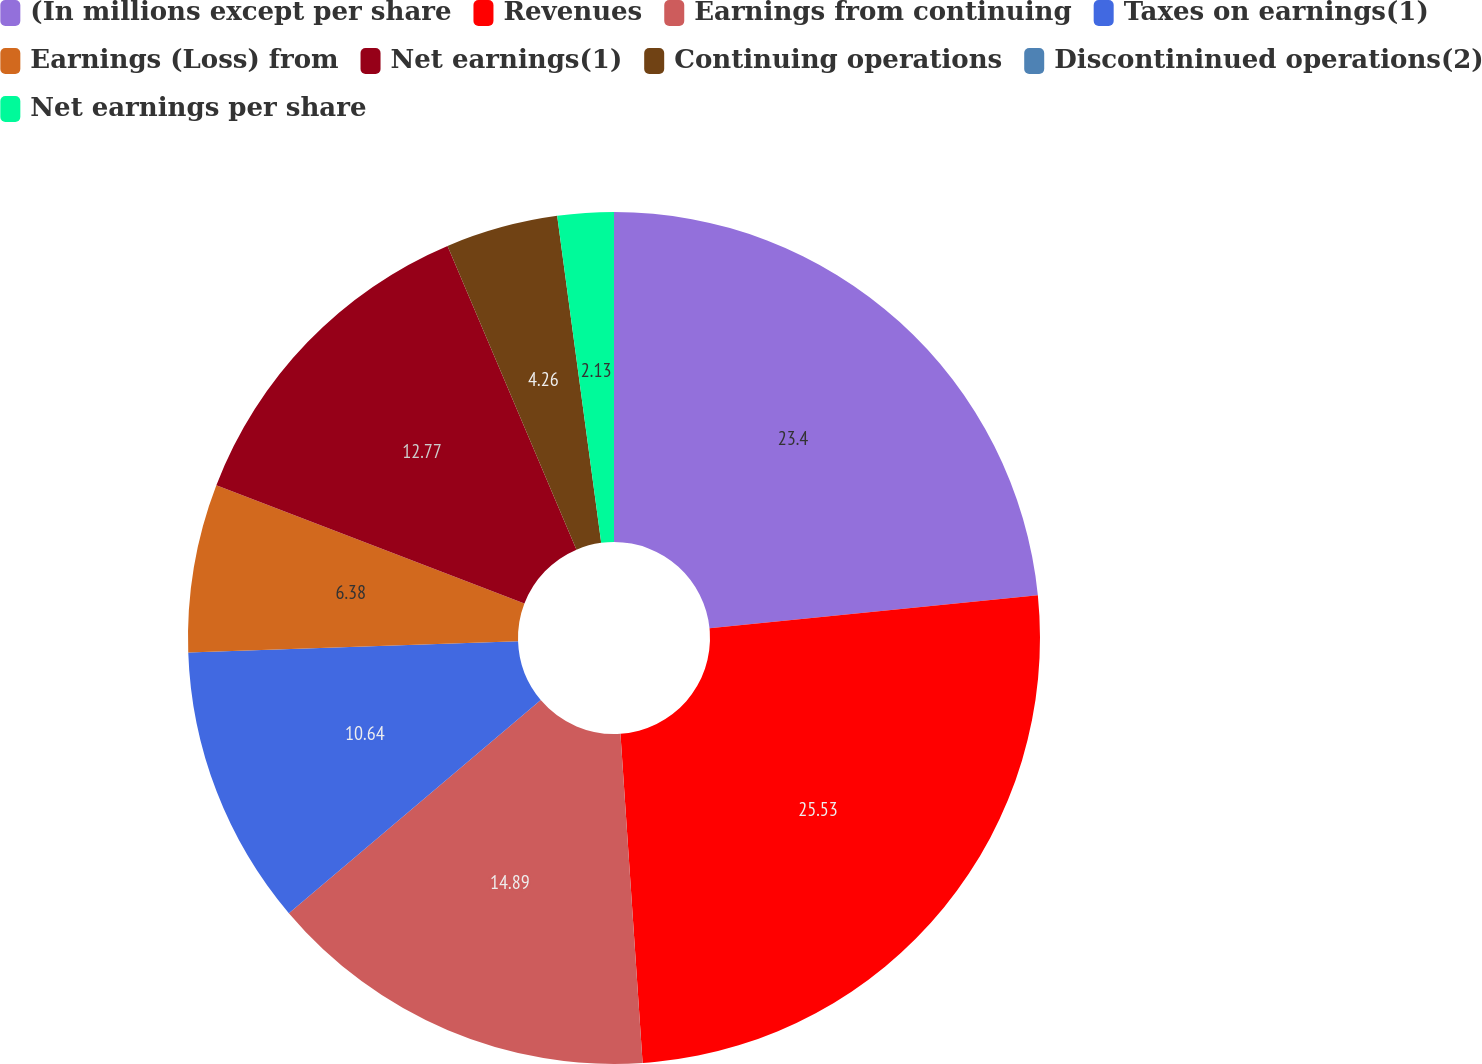Convert chart. <chart><loc_0><loc_0><loc_500><loc_500><pie_chart><fcel>(In millions except per share<fcel>Revenues<fcel>Earnings from continuing<fcel>Taxes on earnings(1)<fcel>Earnings (Loss) from<fcel>Net earnings(1)<fcel>Continuing operations<fcel>Discontininued operations(2)<fcel>Net earnings per share<nl><fcel>23.4%<fcel>25.53%<fcel>14.89%<fcel>10.64%<fcel>6.38%<fcel>12.77%<fcel>4.26%<fcel>0.0%<fcel>2.13%<nl></chart> 